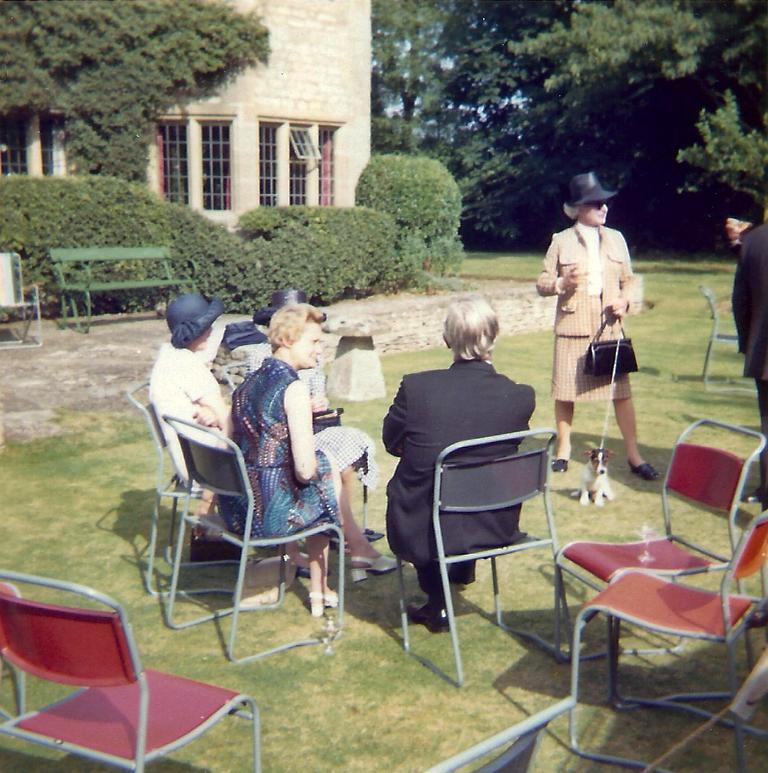Describe this image in one or two sentences. There are four people sitting on the chairs. Here is a woman standing and holding a handbag. These are the empty chairs. These are the small bushes. This is a bench. This looks like a building. These are the trees. 